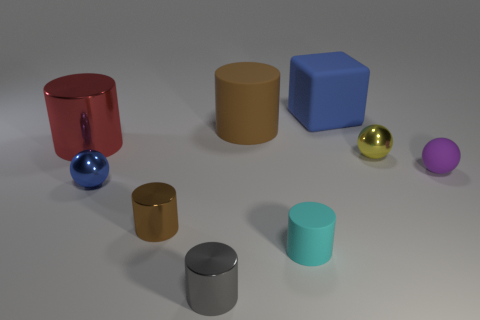Subtract 2 cylinders. How many cylinders are left? 3 Subtract all cyan cylinders. How many cylinders are left? 4 Subtract all small cyan matte cylinders. How many cylinders are left? 4 Add 1 matte spheres. How many objects exist? 10 Subtract all blue cylinders. Subtract all gray blocks. How many cylinders are left? 5 Subtract all blocks. How many objects are left? 8 Add 6 shiny cylinders. How many shiny cylinders are left? 9 Add 8 large red shiny objects. How many large red shiny objects exist? 9 Subtract 1 purple spheres. How many objects are left? 8 Subtract all big blue things. Subtract all small metallic balls. How many objects are left? 6 